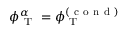Convert formula to latex. <formula><loc_0><loc_0><loc_500><loc_500>\phi _ { T } ^ { \alpha } = \phi _ { T } ^ { ( c o n d ) }</formula> 